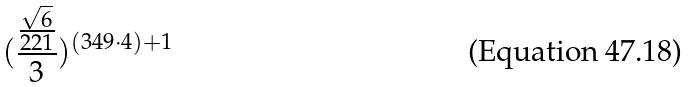<formula> <loc_0><loc_0><loc_500><loc_500>( \frac { \frac { \sqrt { 6 } } { 2 2 1 } } { 3 } ) ^ { ( 3 4 9 \cdot 4 ) + 1 }</formula> 